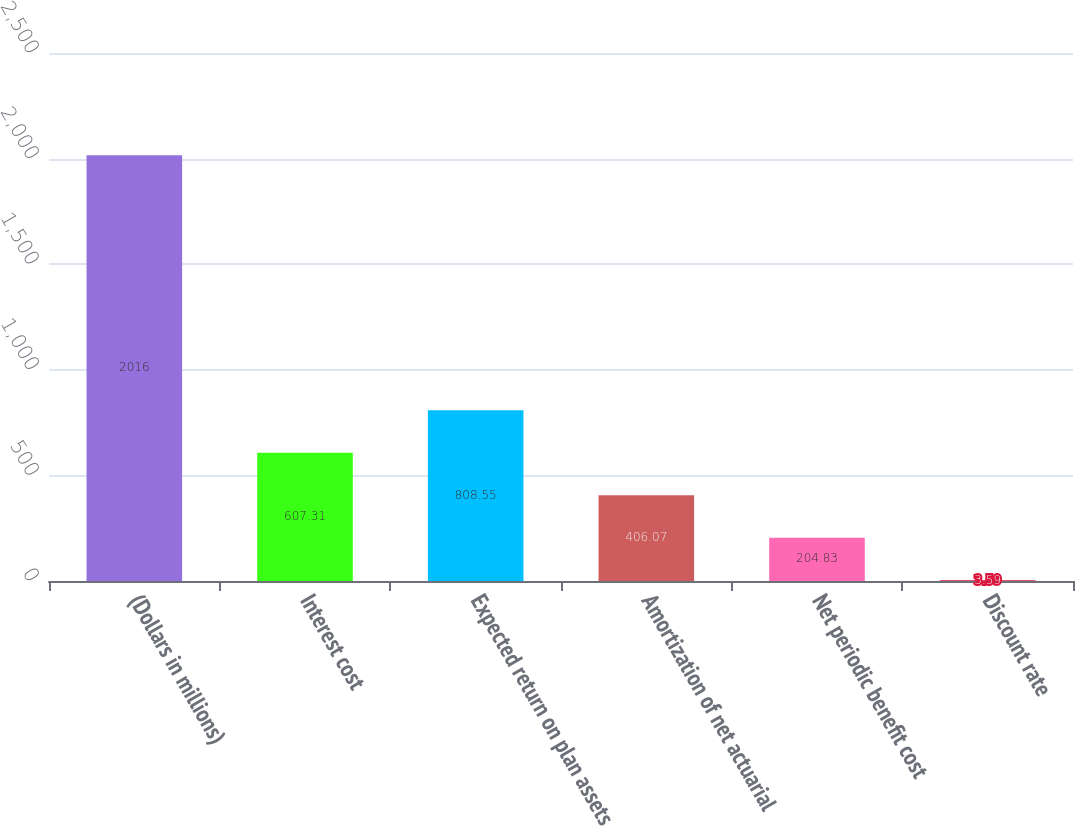<chart> <loc_0><loc_0><loc_500><loc_500><bar_chart><fcel>(Dollars in millions)<fcel>Interest cost<fcel>Expected return on plan assets<fcel>Amortization of net actuarial<fcel>Net periodic benefit cost<fcel>Discount rate<nl><fcel>2016<fcel>607.31<fcel>808.55<fcel>406.07<fcel>204.83<fcel>3.59<nl></chart> 